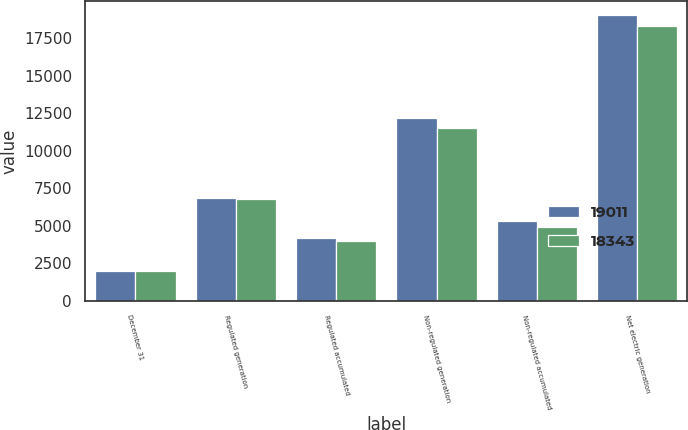Convert chart to OTSL. <chart><loc_0><loc_0><loc_500><loc_500><stacked_bar_chart><ecel><fcel>December 31<fcel>Regulated generation<fcel>Regulated accumulated<fcel>Non-regulated generation<fcel>Non-regulated accumulated<fcel>Net electric generation<nl><fcel>19011<fcel>2016<fcel>6827<fcel>4194<fcel>12184<fcel>5334<fcel>19011<nl><fcel>18343<fcel>2015<fcel>6805<fcel>3984<fcel>11538<fcel>4955<fcel>18343<nl></chart> 